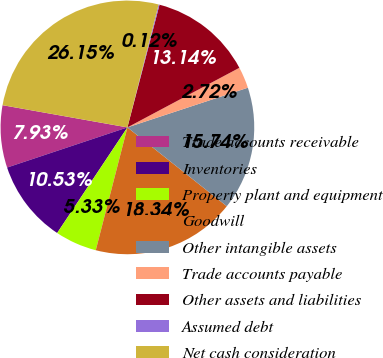Convert chart to OTSL. <chart><loc_0><loc_0><loc_500><loc_500><pie_chart><fcel>Trade accounts receivable<fcel>Inventories<fcel>Property plant and equipment<fcel>Goodwill<fcel>Other intangible assets<fcel>Trade accounts payable<fcel>Other assets and liabilities<fcel>Assumed debt<fcel>Net cash consideration<nl><fcel>7.93%<fcel>10.53%<fcel>5.33%<fcel>18.34%<fcel>15.74%<fcel>2.72%<fcel>13.14%<fcel>0.12%<fcel>26.15%<nl></chart> 